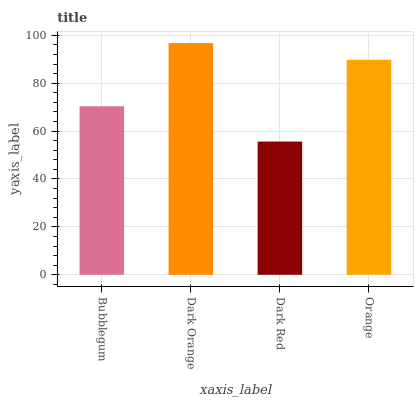Is Dark Red the minimum?
Answer yes or no. Yes. Is Dark Orange the maximum?
Answer yes or no. Yes. Is Dark Orange the minimum?
Answer yes or no. No. Is Dark Red the maximum?
Answer yes or no. No. Is Dark Orange greater than Dark Red?
Answer yes or no. Yes. Is Dark Red less than Dark Orange?
Answer yes or no. Yes. Is Dark Red greater than Dark Orange?
Answer yes or no. No. Is Dark Orange less than Dark Red?
Answer yes or no. No. Is Orange the high median?
Answer yes or no. Yes. Is Bubblegum the low median?
Answer yes or no. Yes. Is Dark Red the high median?
Answer yes or no. No. Is Dark Orange the low median?
Answer yes or no. No. 